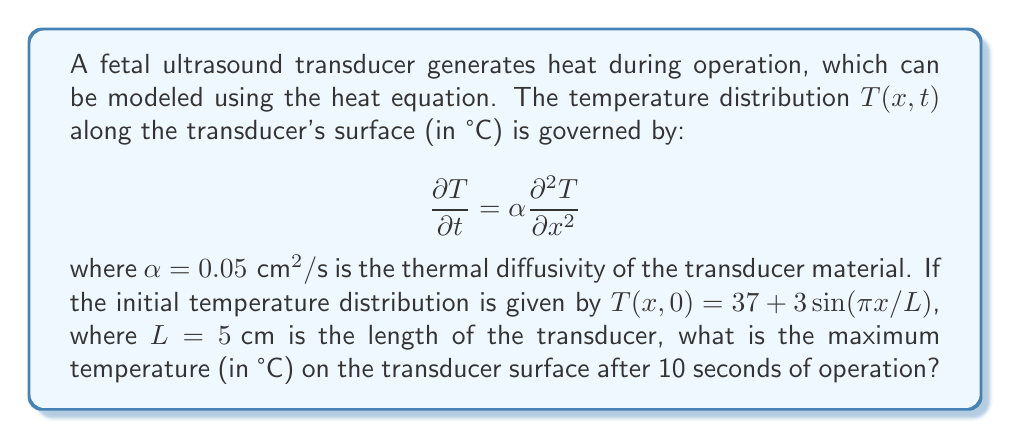Show me your answer to this math problem. To solve this problem, we'll follow these steps:

1) The general solution to the heat equation with the given initial condition is:

   $$T(x,t) = 37 + 3e^{-\alpha(\pi/L)^2t}\sin(\pi x/L)$$

2) We need to find the maximum temperature after 10 seconds, so we'll set $t = 10$:

   $$T(x,10) = 37 + 3e^{-0.05(\pi/5)^2 \cdot 10}\sin(\pi x/5)$$

3) Simplify the exponent:
   $$-0.05(\pi/5)^2 \cdot 10 = -0.05 \cdot (\pi^2/25) \cdot 10 = -0.2\pi^2/5 \approx -1.2337$$

4) Our equation becomes:
   $$T(x,10) = 37 + 3e^{-1.2337}\sin(\pi x/5)$$

5) Calculate $e^{-1.2337} \approx 0.2911$

6) Simplify further:
   $$T(x,10) = 37 + 0.8733\sin(\pi x/5)$$

7) The maximum temperature will occur when $\sin(\pi x/5)$ is at its maximum value of 1.

8) Therefore, the maximum temperature is:
   $$T_{max} = 37 + 0.8733 = 37.8733 \text{ °C}$$
Answer: 37.87 °C 